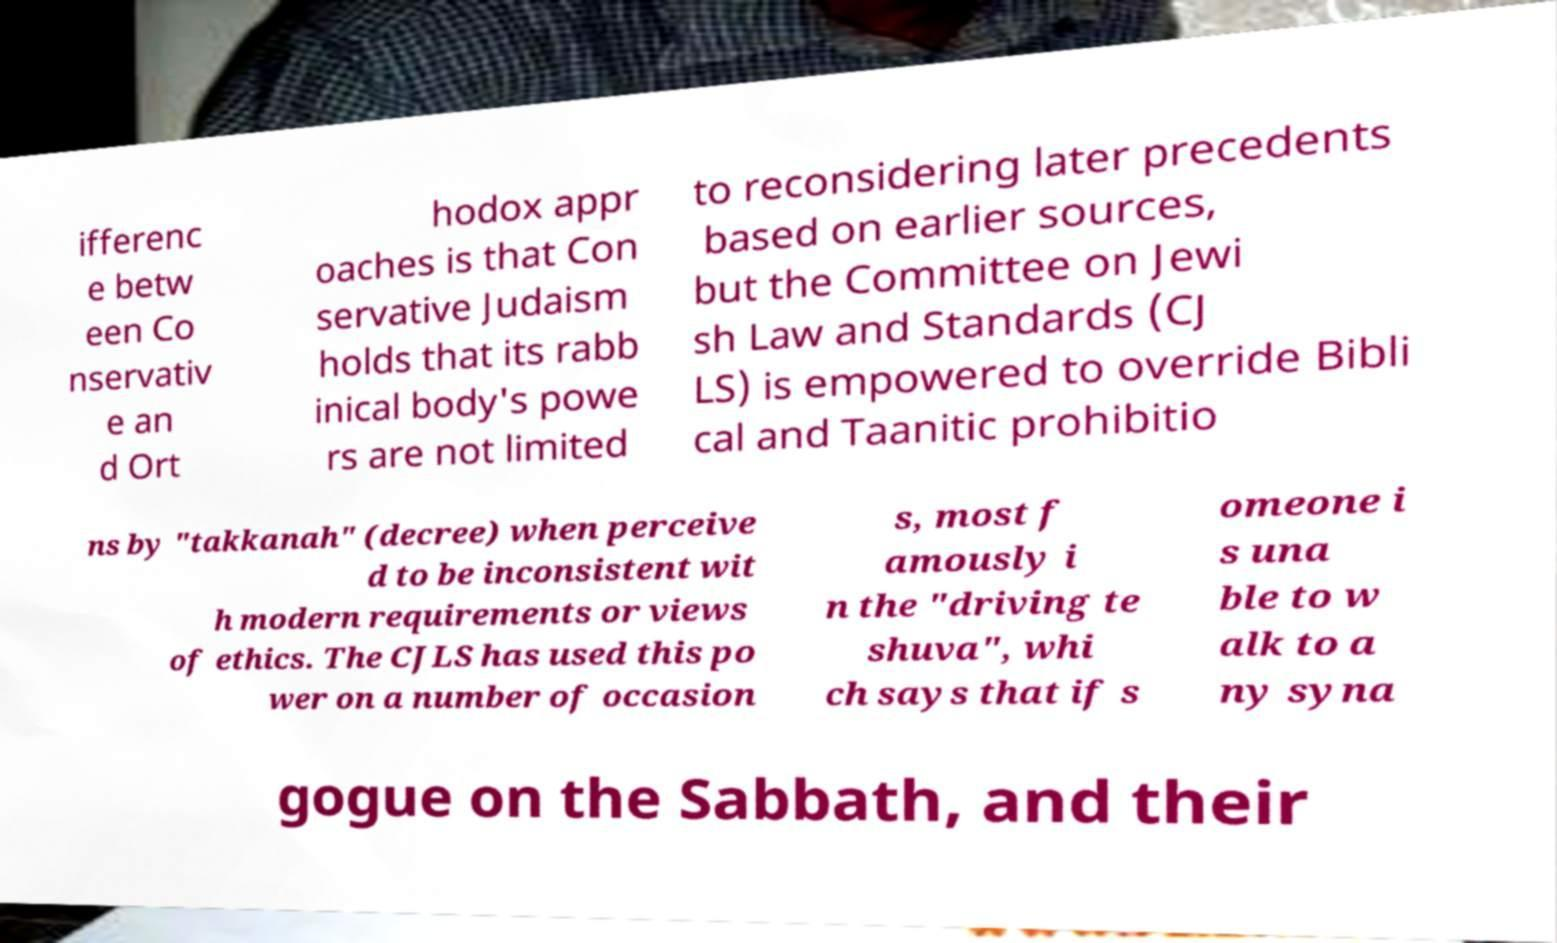There's text embedded in this image that I need extracted. Can you transcribe it verbatim? ifferenc e betw een Co nservativ e an d Ort hodox appr oaches is that Con servative Judaism holds that its rabb inical body's powe rs are not limited to reconsidering later precedents based on earlier sources, but the Committee on Jewi sh Law and Standards (CJ LS) is empowered to override Bibli cal and Taanitic prohibitio ns by "takkanah" (decree) when perceive d to be inconsistent wit h modern requirements or views of ethics. The CJLS has used this po wer on a number of occasion s, most f amously i n the "driving te shuva", whi ch says that if s omeone i s una ble to w alk to a ny syna gogue on the Sabbath, and their 